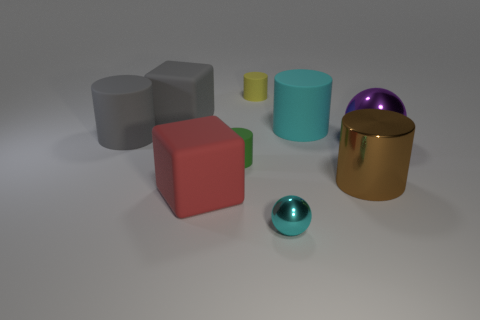Is the shape of the yellow rubber object the same as the big shiny thing in front of the big purple metal thing?
Keep it short and to the point. Yes. How many other objects are the same material as the cyan cylinder?
Your answer should be very brief. 5. There is a big metal ball; is its color the same as the block that is in front of the big gray matte cube?
Offer a terse response. No. There is a cyan object that is behind the tiny shiny sphere; what material is it?
Offer a terse response. Rubber. Is there a small metallic ball that has the same color as the big shiny sphere?
Give a very brief answer. No. There is a shiny sphere that is the same size as the yellow cylinder; what color is it?
Provide a short and direct response. Cyan. What number of big things are either cyan matte objects or cyan metal objects?
Ensure brevity in your answer.  1. Are there the same number of green objects in front of the small cyan shiny object and brown metal objects that are behind the large brown metallic object?
Make the answer very short. Yes. What number of cyan metallic spheres have the same size as the brown metallic cylinder?
Offer a terse response. 0. What number of gray objects are large rubber things or matte blocks?
Keep it short and to the point. 2. 